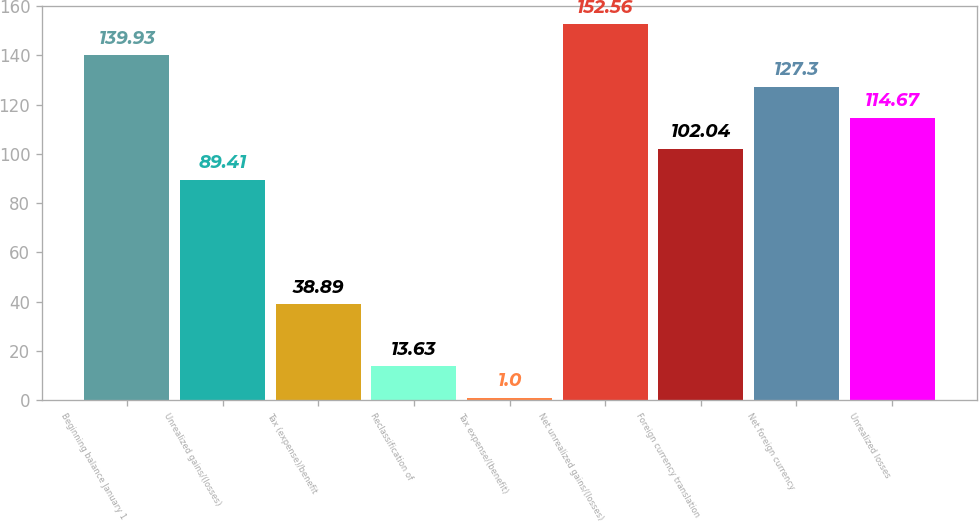Convert chart. <chart><loc_0><loc_0><loc_500><loc_500><bar_chart><fcel>Beginning balance January 1<fcel>Unrealized gains/(losses)<fcel>Tax (expense)/benefit<fcel>Reclassification of<fcel>Tax expense/(benefit)<fcel>Net unrealized gains/(losses)<fcel>Foreign currency translation<fcel>Net foreign currency<fcel>Unrealized losses<nl><fcel>139.93<fcel>89.41<fcel>38.89<fcel>13.63<fcel>1<fcel>152.56<fcel>102.04<fcel>127.3<fcel>114.67<nl></chart> 